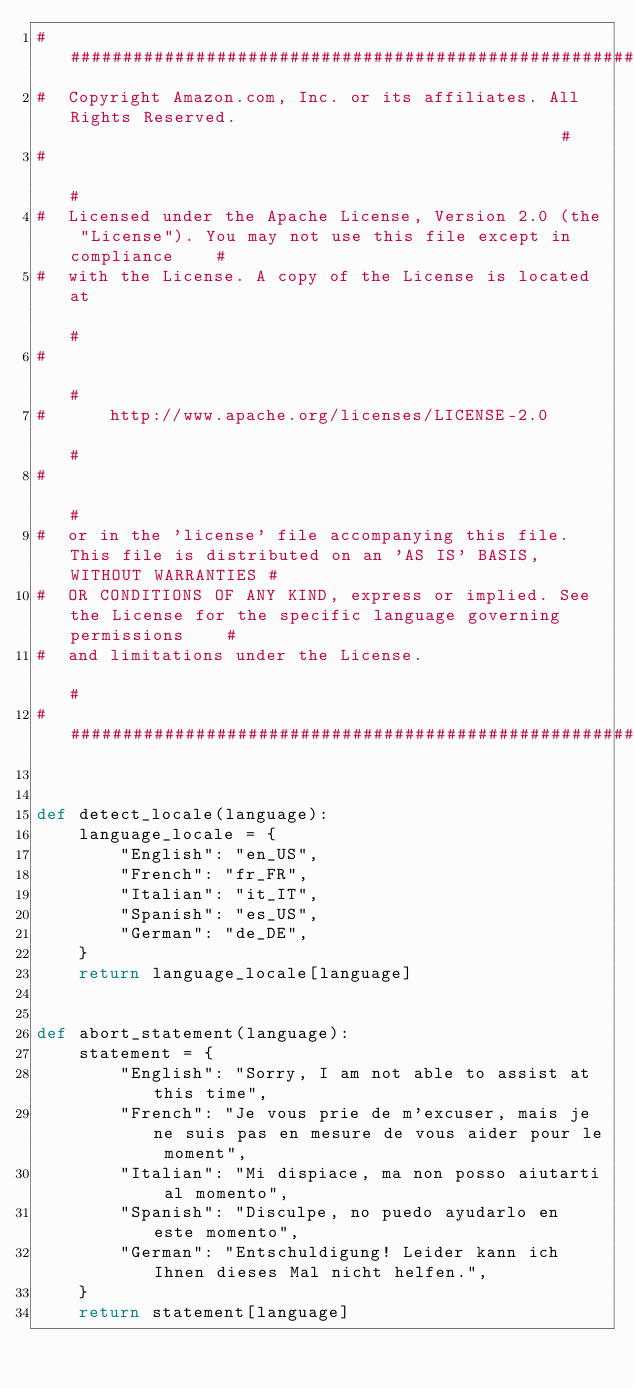<code> <loc_0><loc_0><loc_500><loc_500><_Python_>######################################################################################################################
#  Copyright Amazon.com, Inc. or its affiliates. All Rights Reserved.                                                #
#                                                                                                                    #
#  Licensed under the Apache License, Version 2.0 (the "License"). You may not use this file except in compliance    #
#  with the License. A copy of the License is located at                                                             #
#                                                                                                                    #
#      http://www.apache.org/licenses/LICENSE-2.0                                                                    #
#                                                                                                                    #
#  or in the 'license' file accompanying this file. This file is distributed on an 'AS IS' BASIS, WITHOUT WARRANTIES #
#  OR CONDITIONS OF ANY KIND, express or implied. See the License for the specific language governing permissions    #
#  and limitations under the License.                                                                                #
######################################################################################################################


def detect_locale(language):
    language_locale = {
        "English": "en_US",
        "French": "fr_FR",
        "Italian": "it_IT",
        "Spanish": "es_US",
        "German": "de_DE",
    }
    return language_locale[language]


def abort_statement(language):
    statement = {
        "English": "Sorry, I am not able to assist at this time",
        "French": "Je vous prie de m'excuser, mais je ne suis pas en mesure de vous aider pour le moment",
        "Italian": "Mi dispiace, ma non posso aiutarti al momento",
        "Spanish": "Disculpe, no puedo ayudarlo en este momento",
        "German": "Entschuldigung! Leider kann ich Ihnen dieses Mal nicht helfen.",
    }
    return statement[language]
</code> 